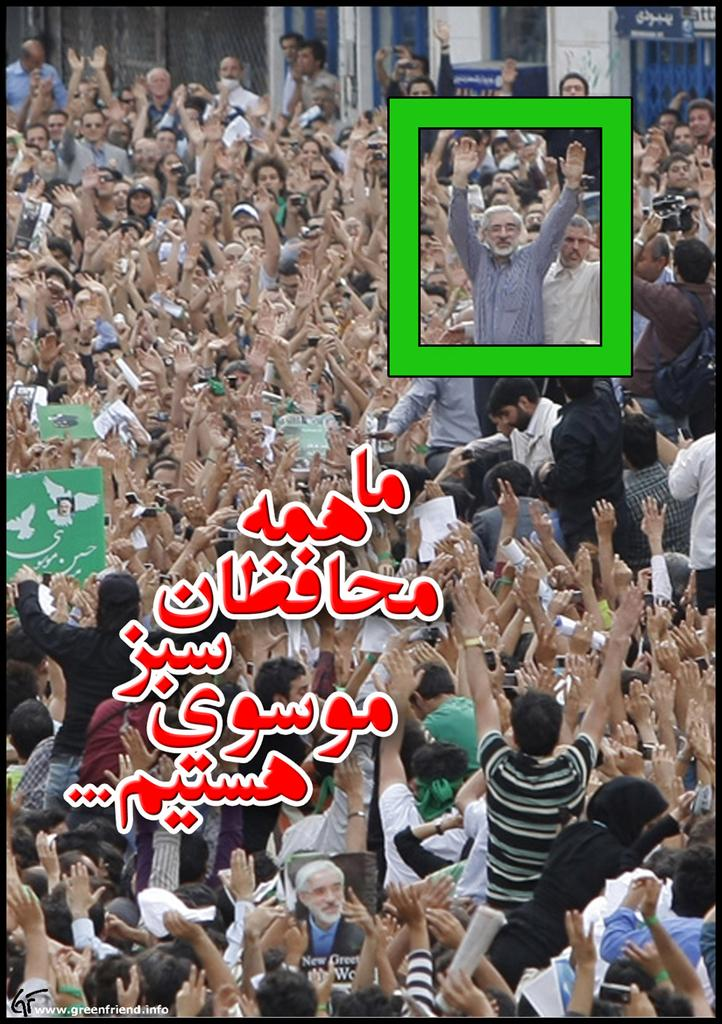What is happening with the group of people in the image? The people in the image have their hands up. What can be seen in the background of the image? There is a building in the background of the image. Is there any text visible in the image? Yes, there is some text visible in the image. What type of bun is the manager holding in the image? There is no bun or manager present in the image. How many teeth can be seen in the mouth of the person in the image? There is no person's mouth visible in the image, so it is not possible to determine the number of teeth. 